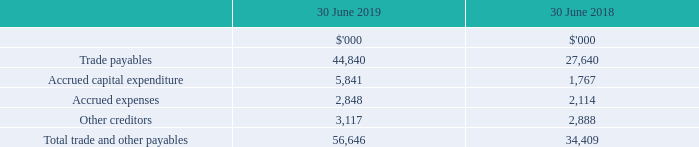7 Trade and other payables
(i) Recognition and measurement
Trade and other payables, including accruals, are recorded when the Group is required to make future payments as a result of purchases of assets or services provided to the Group prior to the end of financial period. The amounts are unsecured and are usually paid within 30 days of recognition. Trade and other payables are presented as current liabilities unless payment is not due within 12 months from the reporting date. They are recognised initially at their fair value and subsequently measured at amortised cost using the effective interest method.
(ii) Fair values of trade and other payables
Due to the short-term nature of trade and other payables, their carrying amount is considered to be the same as their fair value.
(iii) Risk Exposure
As the majority of payables are in Australian dollars, management does not believe there are any significant risks in relation to these financial liabilities. Refer to note 15 for details of the Group’s financial risk management policies.
How was trade payables recognised and measured? Recognised initially at their fair value and subsequently measured at amortised cost using the effective interest method. Why was the carrying amount of trade payables considered to be the same as their fair value? Due to the short-term nature of trade and other payables. How much was the trade payables for 2019?
Answer scale should be: thousand. 44,840. What was the percentage change in accrued expenses between 2018 and 2019?
Answer scale should be: percent. (2,848 -2,114) / 2,114 
Answer: 34.72. What was the sum of accrued expenses and accrued capital expenditure in 2018?
Answer scale should be: thousand. 1,767 + 2,114 
Answer: 3881. What was the percentage change in total trade and other payables between 2018 and 2019?
Answer scale should be: percent. (56,646 - 34,409) / 34,409 
Answer: 64.63. 